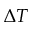Convert formula to latex. <formula><loc_0><loc_0><loc_500><loc_500>\Delta T</formula> 